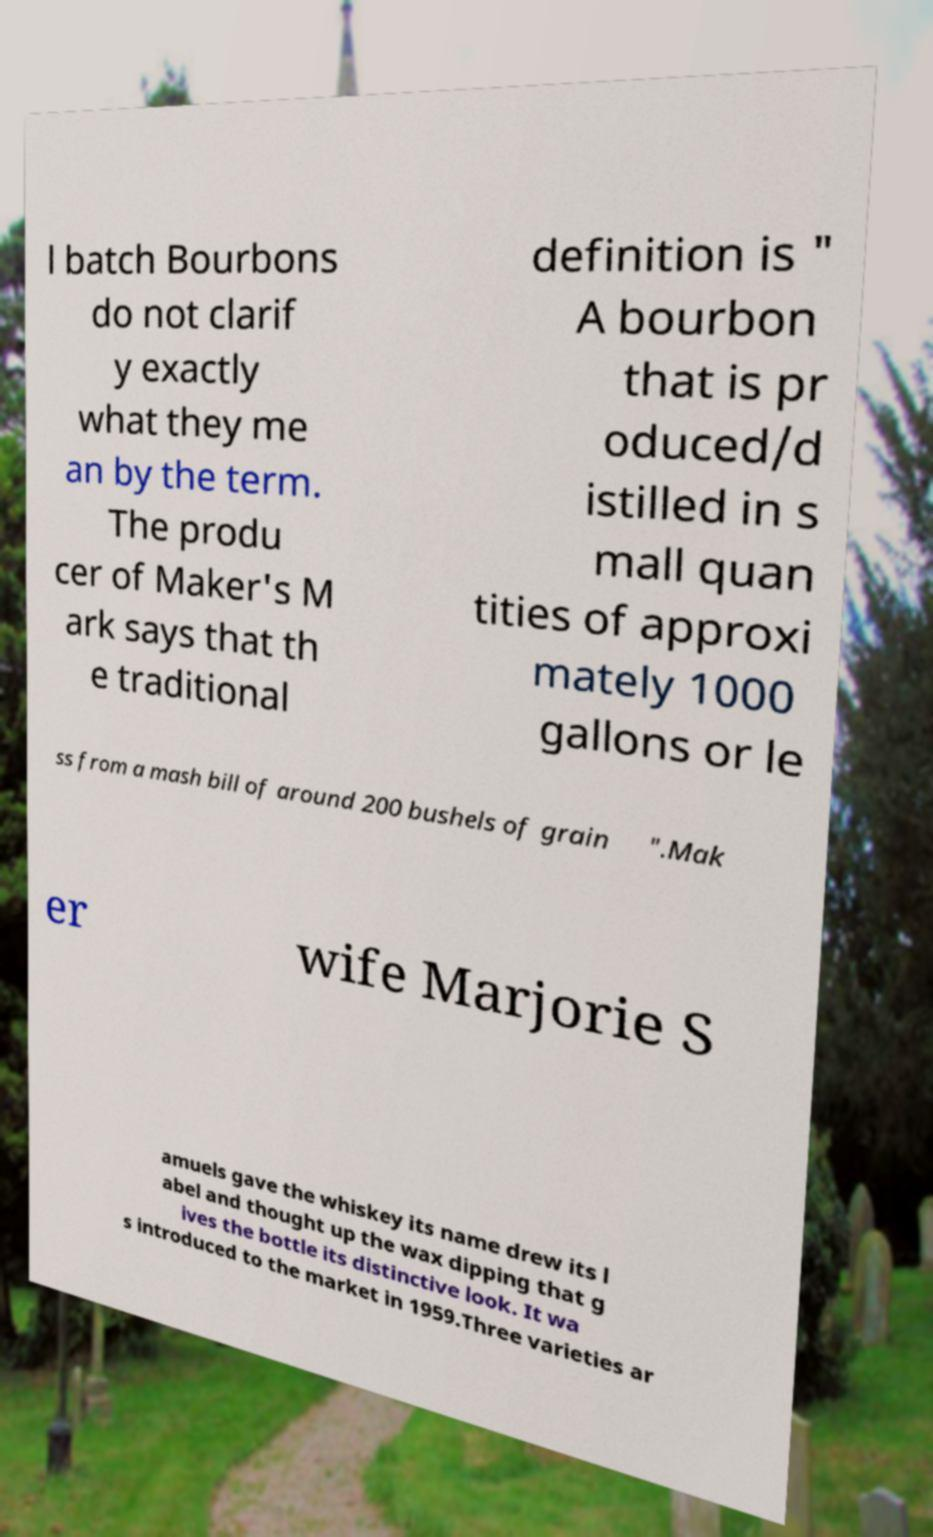I need the written content from this picture converted into text. Can you do that? l batch Bourbons do not clarif y exactly what they me an by the term. The produ cer of Maker's M ark says that th e traditional definition is " A bourbon that is pr oduced/d istilled in s mall quan tities of approxi mately 1000 gallons or le ss from a mash bill of around 200 bushels of grain ".Mak er wife Marjorie S amuels gave the whiskey its name drew its l abel and thought up the wax dipping that g ives the bottle its distinctive look. It wa s introduced to the market in 1959.Three varieties ar 